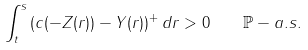<formula> <loc_0><loc_0><loc_500><loc_500>\int _ { t } ^ { s } \left ( c ( - Z ( r ) ) - Y ( r ) \right ) ^ { + } d r > 0 \quad \mathbb { P } - a . s .</formula> 